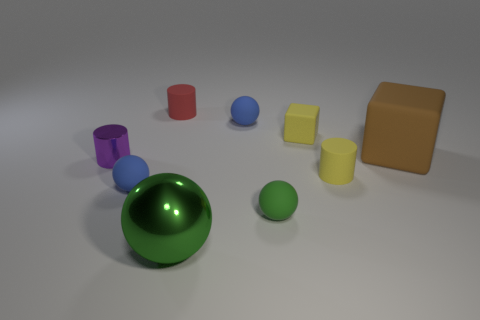What is the material of the sphere that is the same color as the big metal object?
Make the answer very short. Rubber. There is a object that is to the right of the small yellow rubber cube and on the left side of the big rubber thing; what size is it?
Your answer should be compact. Small. What number of purple things are either large cubes or tiny shiny objects?
Your response must be concise. 1. There is a thing that is the same size as the green metallic ball; what shape is it?
Make the answer very short. Cube. How many other things are there of the same color as the shiny cylinder?
Your response must be concise. 0. What size is the sphere behind the blue rubber sphere in front of the big brown thing?
Your response must be concise. Small. Is the material of the large thing left of the green matte ball the same as the small block?
Your answer should be very brief. No. What is the shape of the small blue thing left of the big metal sphere?
Give a very brief answer. Sphere. What number of purple blocks are the same size as the red rubber cylinder?
Keep it short and to the point. 0. The green matte thing has what size?
Your response must be concise. Small. 